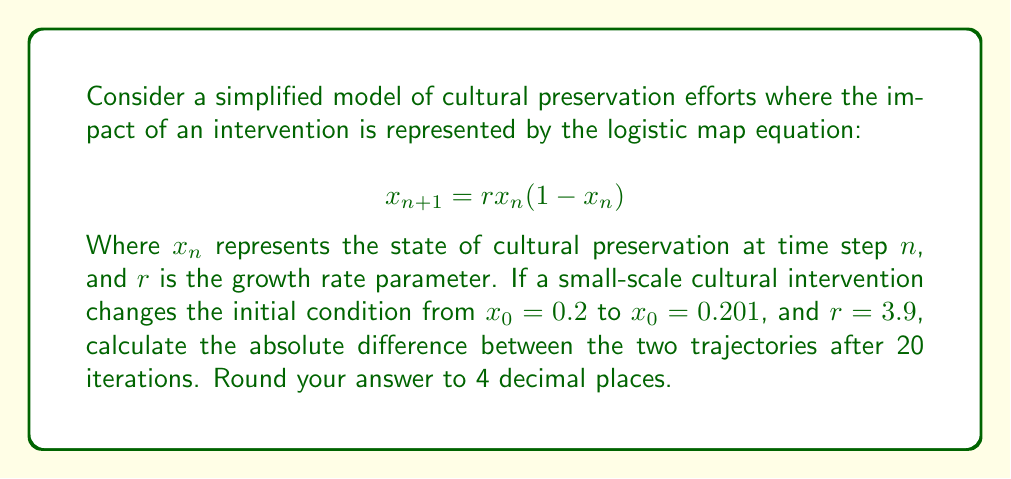Can you solve this math problem? To solve this problem, we need to iterate the logistic map equation for both initial conditions and compare the results. Let's break it down step-by-step:

1. Define two initial conditions:
   $x_0^{(1)} = 0.2$ (original)
   $x_0^{(2)} = 0.201$ (after intervention)

2. Set up the logistic map equation with $r = 3.9$:
   $$ x_{n+1} = 3.9x_n(1-x_n) $$

3. Iterate this equation 20 times for both initial conditions:

   For $x_0^{(1)} = 0.2$:
   $x_1^{(1)} = 3.9 * 0.2 * (1-0.2) = 0.624$
   $x_2^{(1)} = 3.9 * 0.624 * (1-0.624) = 0.9161664$
   ...
   $x_{20}^{(1)} = 0.5250678762$

   For $x_0^{(2)} = 0.201$:
   $x_1^{(2)} = 3.9 * 0.201 * (1-0.201) = 0.6260961$
   $x_2^{(2)} = 3.9 * 0.6260961 * (1-0.6260961) = 0.9145437$
   ...
   $x_{20}^{(2)} = 0.8743560516$

4. Calculate the absolute difference between the two final values:
   $|\Delta x_{20}| = |x_{20}^{(1)} - x_{20}^{(2)}|$
   $|\Delta x_{20}| = |0.5250678762 - 0.8743560516|$
   $|\Delta x_{20}| = 0.3492881754$

5. Round the result to 4 decimal places:
   $|\Delta x_{20}| \approx 0.3493$

This significant difference after only 20 iterations, despite a tiny initial change, demonstrates the butterfly effect in cultural preservation efforts.
Answer: 0.3493 